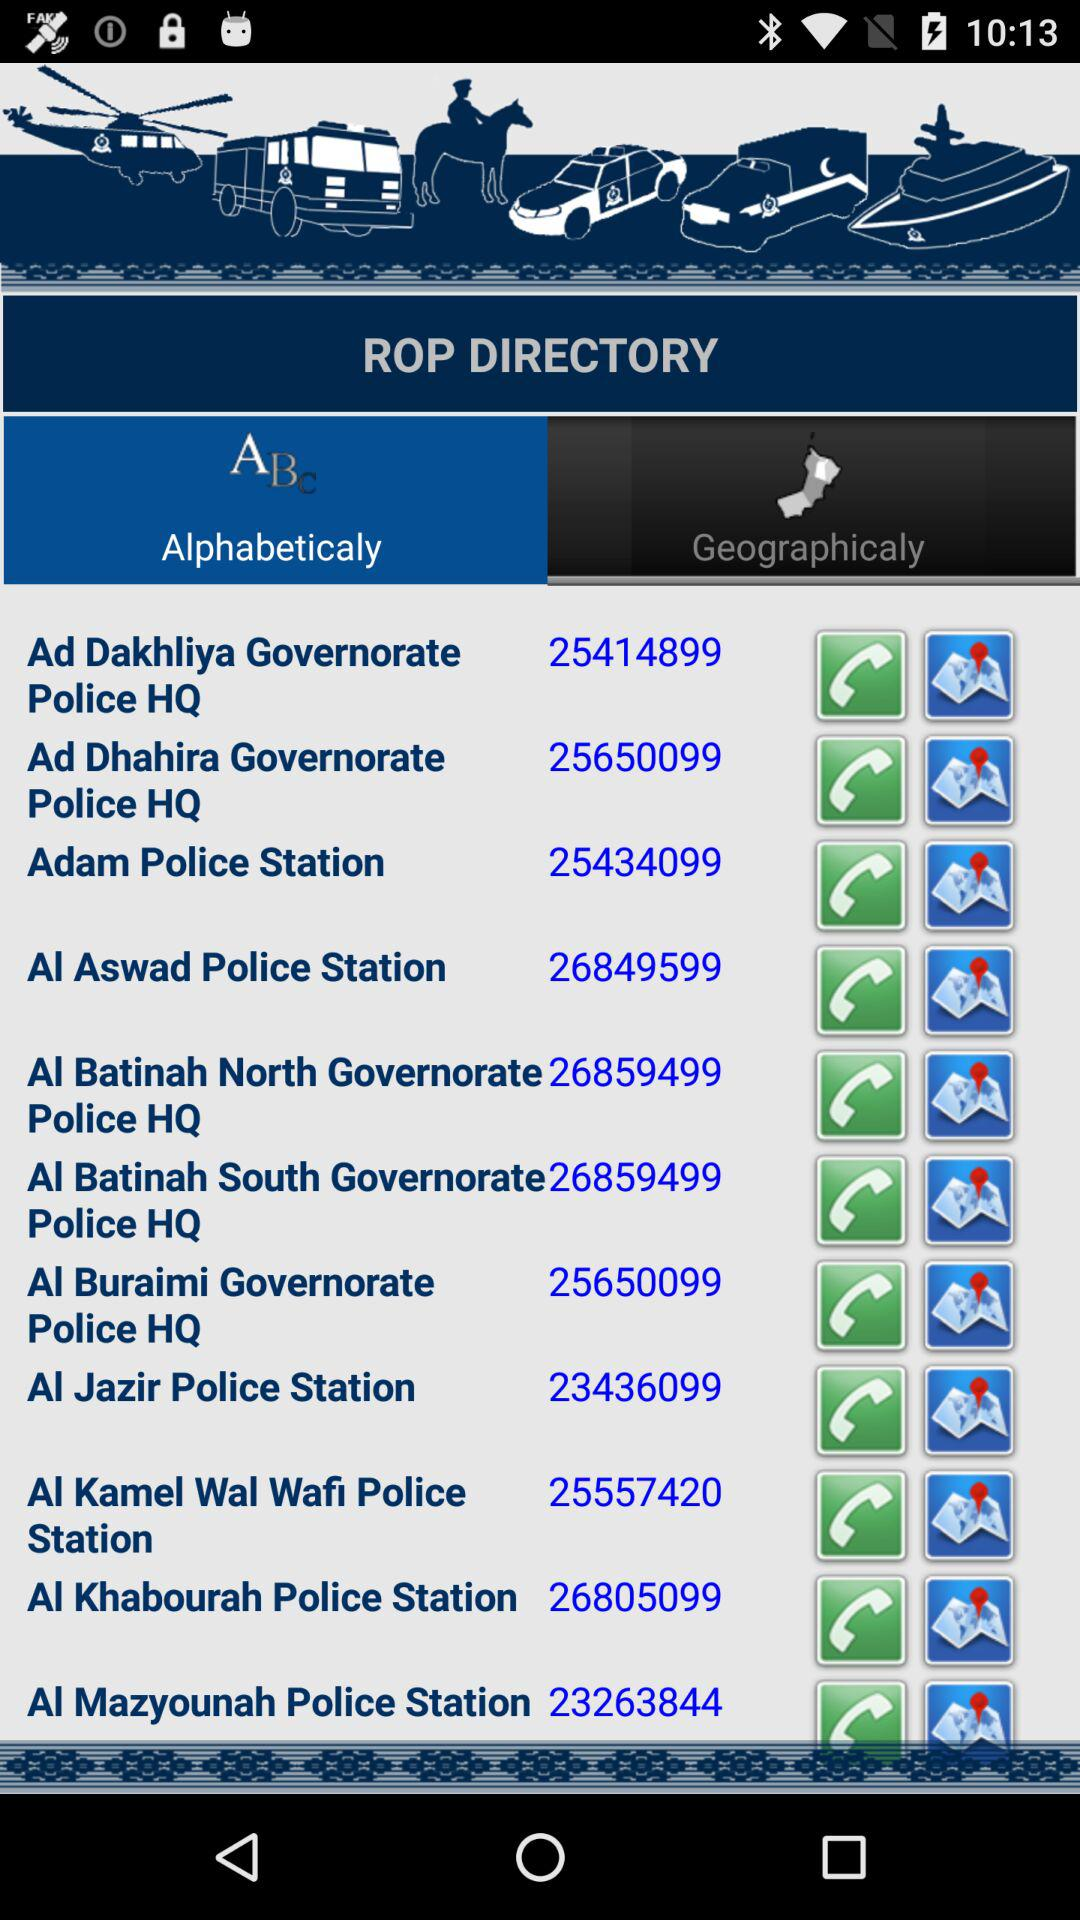What's the number of Adam police station? The number of Adam police station is 25434099. 